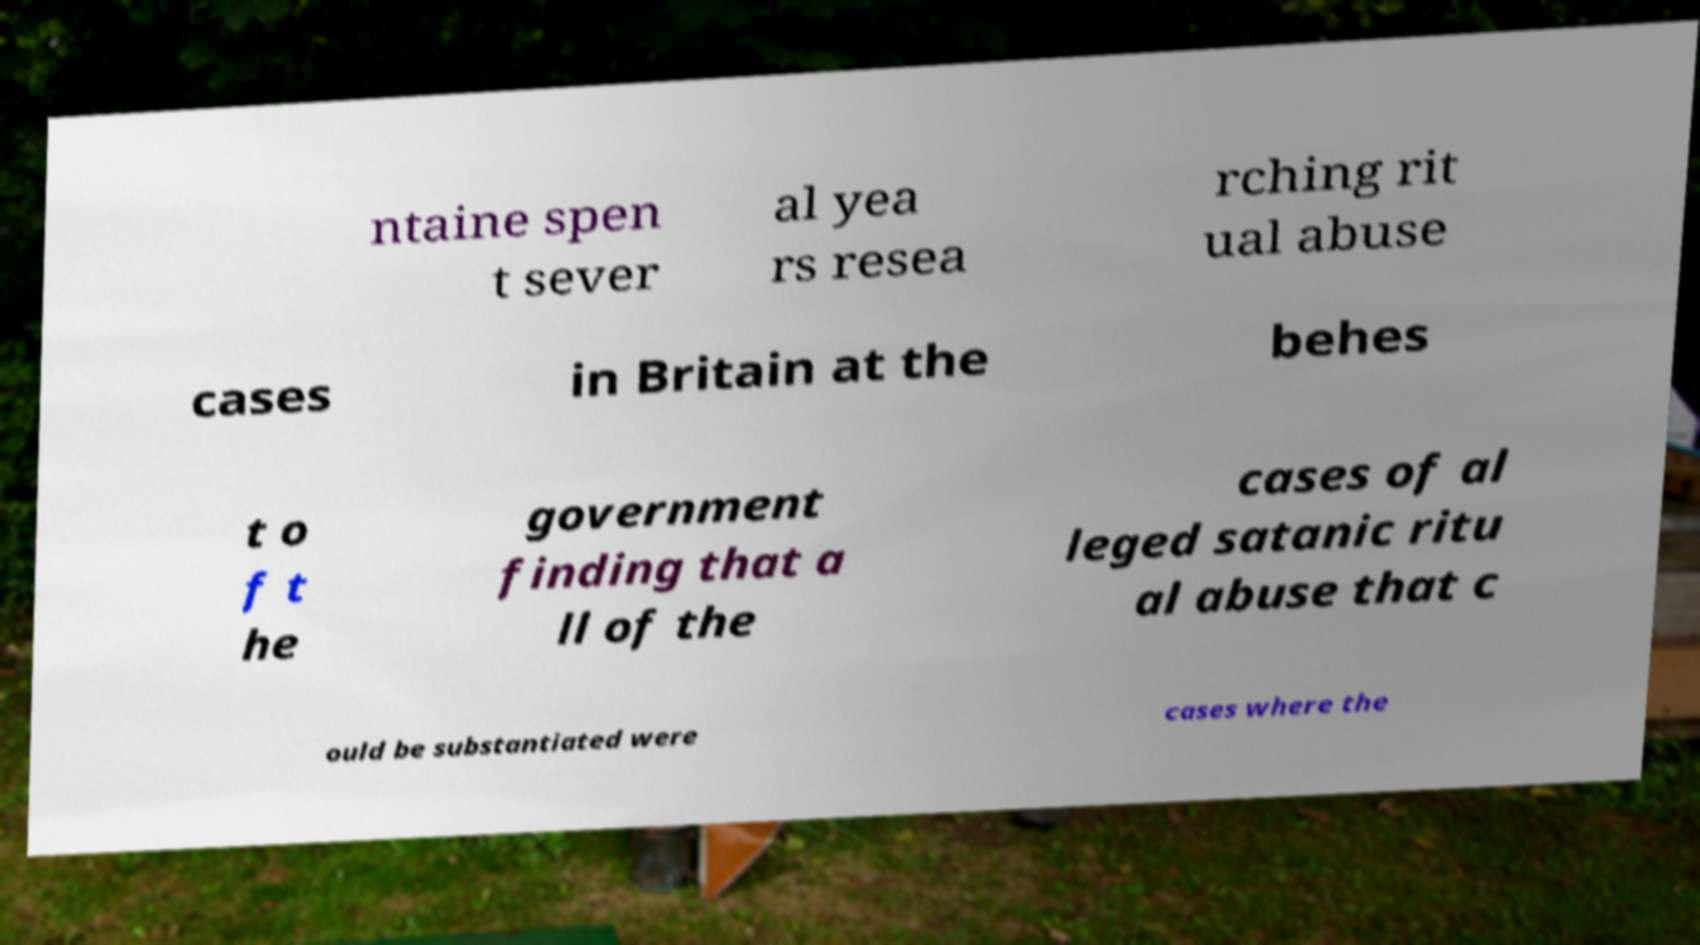I need the written content from this picture converted into text. Can you do that? ntaine spen t sever al yea rs resea rching rit ual abuse cases in Britain at the behes t o f t he government finding that a ll of the cases of al leged satanic ritu al abuse that c ould be substantiated were cases where the 